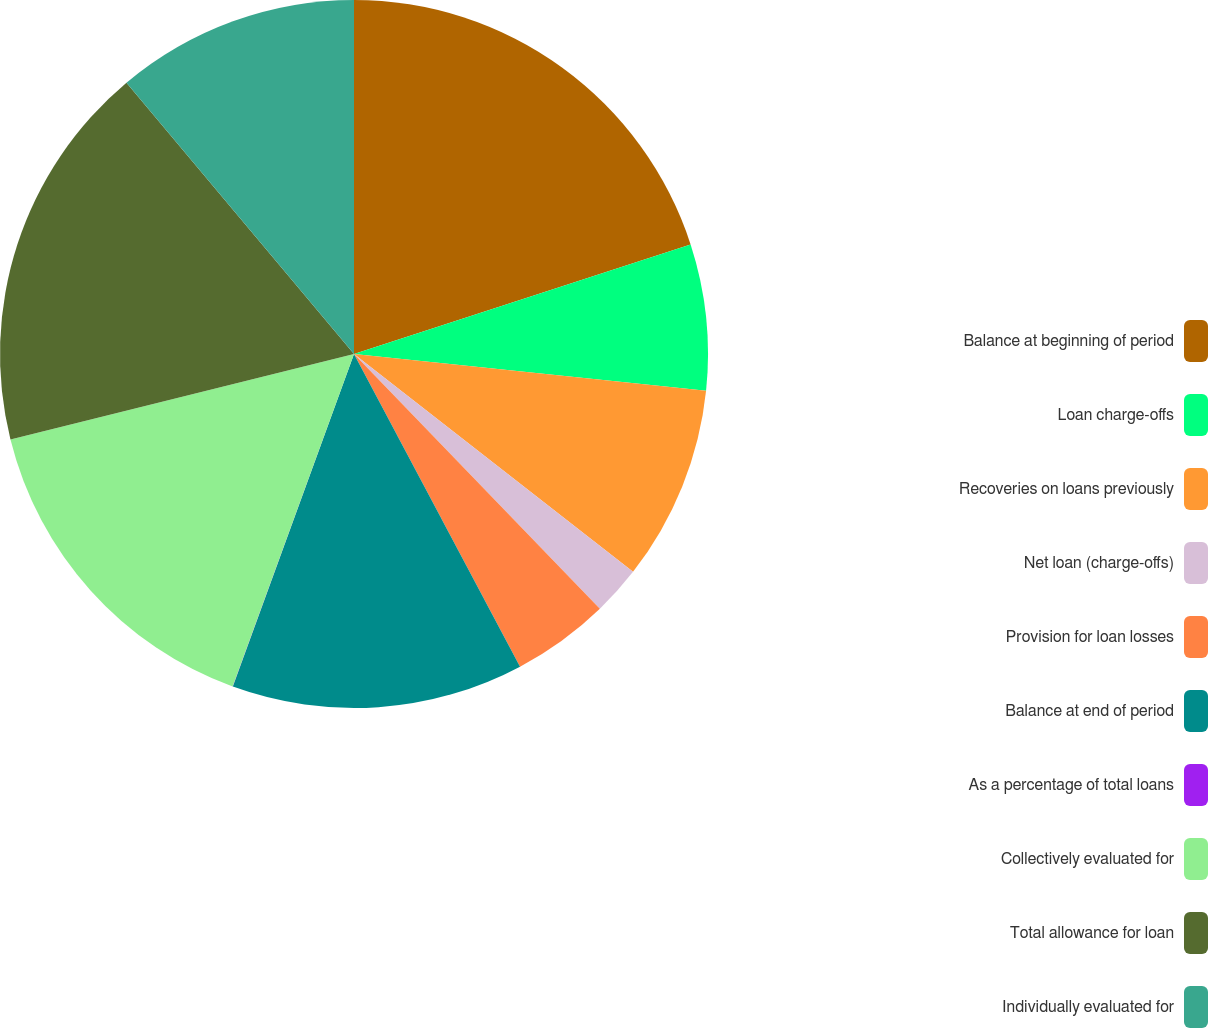<chart> <loc_0><loc_0><loc_500><loc_500><pie_chart><fcel>Balance at beginning of period<fcel>Loan charge-offs<fcel>Recoveries on loans previously<fcel>Net loan (charge-offs)<fcel>Provision for loan losses<fcel>Balance at end of period<fcel>As a percentage of total loans<fcel>Collectively evaluated for<fcel>Total allowance for loan<fcel>Individually evaluated for<nl><fcel>19.99%<fcel>6.67%<fcel>8.89%<fcel>2.23%<fcel>4.45%<fcel>13.33%<fcel>0.01%<fcel>15.55%<fcel>17.77%<fcel>11.11%<nl></chart> 